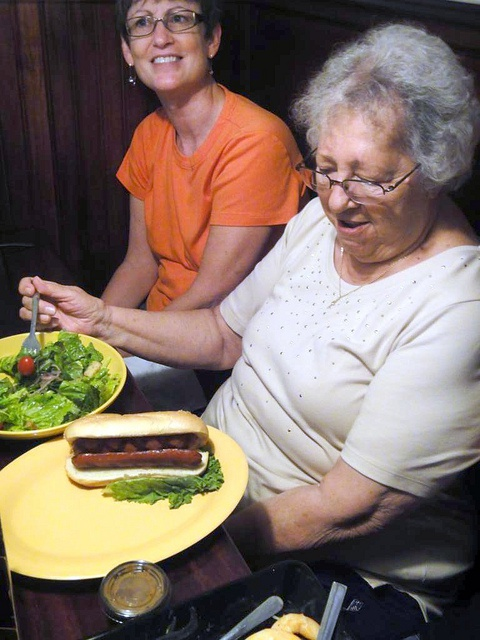Describe the objects in this image and their specific colors. I can see people in black, lightgray, darkgray, and gray tones, dining table in black, khaki, darkgreen, and maroon tones, people in black, brown, salmon, and red tones, bowl in black, darkgreen, olive, and khaki tones, and hot dog in black, beige, maroon, and khaki tones in this image. 